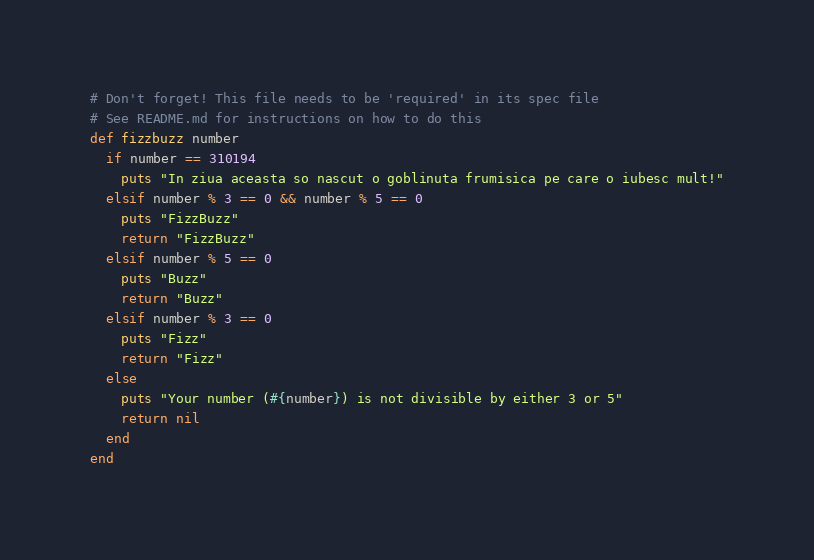<code> <loc_0><loc_0><loc_500><loc_500><_Ruby_># Don't forget! This file needs to be 'required' in its spec file
# See README.md for instructions on how to do this
def fizzbuzz number
  if number == 310194
    puts "In ziua aceasta so nascut o goblinuta frumisica pe care o iubesc mult!"
  elsif number % 3 == 0 && number % 5 == 0
    puts "FizzBuzz"
    return "FizzBuzz"
  elsif number % 5 == 0
    puts "Buzz"
    return "Buzz"
  elsif number % 3 == 0
    puts "Fizz"
    return "Fizz"
  else
    puts "Your number (#{number}) is not divisible by either 3 or 5"
    return nil
  end
end
</code> 